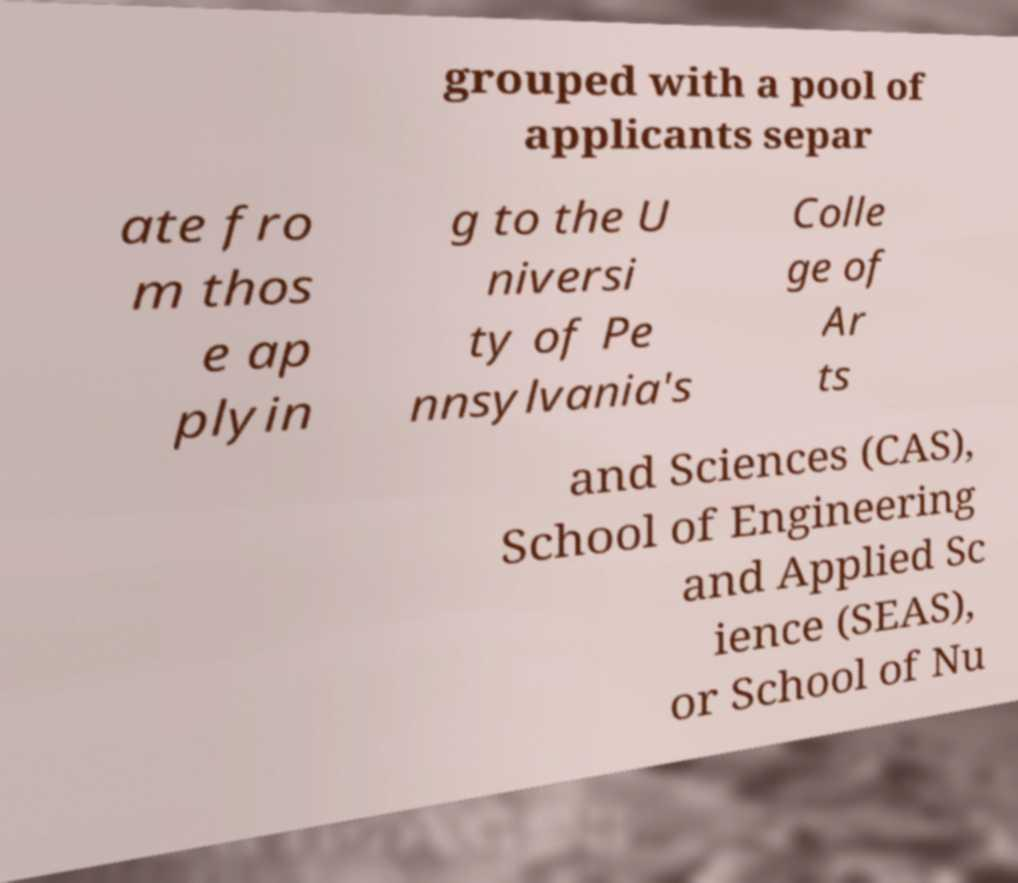What messages or text are displayed in this image? I need them in a readable, typed format. grouped with a pool of applicants separ ate fro m thos e ap plyin g to the U niversi ty of Pe nnsylvania's Colle ge of Ar ts and Sciences (CAS), School of Engineering and Applied Sc ience (SEAS), or School of Nu 